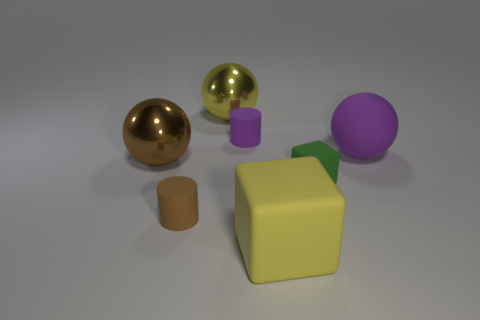How many large yellow rubber things are the same shape as the big purple rubber thing?
Keep it short and to the point. 0. What number of big cubes are there?
Keep it short and to the point. 1. There is a brown thing that is in front of the small green matte block; is its shape the same as the small purple thing?
Offer a terse response. Yes. What material is the purple cylinder that is the same size as the green thing?
Give a very brief answer. Rubber. Are there any purple cylinders made of the same material as the green thing?
Provide a succinct answer. Yes. There is a yellow shiny thing; is its shape the same as the tiny matte thing that is left of the purple cylinder?
Make the answer very short. No. How many rubber cylinders are both left of the small purple rubber thing and on the right side of the small brown cylinder?
Give a very brief answer. 0. Do the green object and the large yellow object that is behind the green cube have the same material?
Offer a terse response. No. Are there the same number of small purple cylinders that are behind the yellow shiny object and big green cylinders?
Ensure brevity in your answer.  Yes. What is the color of the metallic thing that is behind the rubber ball?
Make the answer very short. Yellow. 